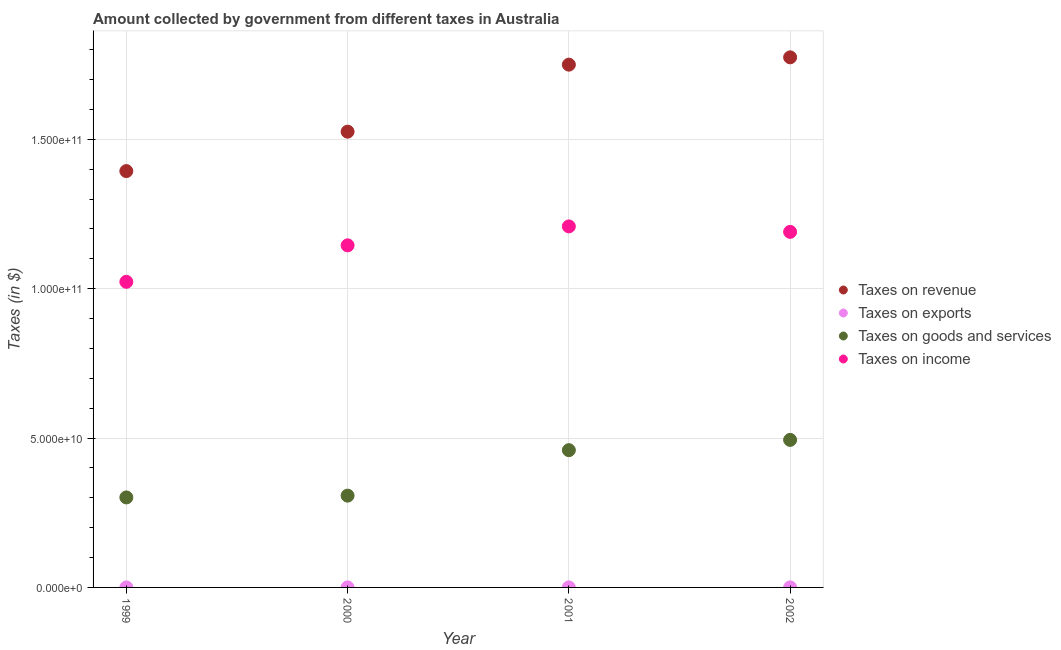Is the number of dotlines equal to the number of legend labels?
Keep it short and to the point. Yes. What is the amount collected as tax on income in 2002?
Provide a short and direct response. 1.19e+11. Across all years, what is the maximum amount collected as tax on income?
Provide a succinct answer. 1.21e+11. Across all years, what is the minimum amount collected as tax on goods?
Your response must be concise. 3.01e+1. In which year was the amount collected as tax on goods maximum?
Offer a terse response. 2002. In which year was the amount collected as tax on exports minimum?
Keep it short and to the point. 1999. What is the total amount collected as tax on income in the graph?
Provide a short and direct response. 4.57e+11. What is the difference between the amount collected as tax on income in 2000 and that in 2002?
Your answer should be compact. -4.51e+09. What is the difference between the amount collected as tax on goods in 1999 and the amount collected as tax on income in 2002?
Offer a terse response. -8.89e+1. What is the average amount collected as tax on revenue per year?
Give a very brief answer. 1.61e+11. In the year 1999, what is the difference between the amount collected as tax on revenue and amount collected as tax on exports?
Make the answer very short. 1.39e+11. In how many years, is the amount collected as tax on goods greater than 50000000000 $?
Offer a very short reply. 0. What is the ratio of the amount collected as tax on revenue in 2001 to that in 2002?
Offer a very short reply. 0.99. Is the amount collected as tax on revenue in 2000 less than that in 2002?
Your response must be concise. Yes. Is the difference between the amount collected as tax on goods in 2001 and 2002 greater than the difference between the amount collected as tax on revenue in 2001 and 2002?
Your answer should be very brief. No. What is the difference between the highest and the second highest amount collected as tax on goods?
Make the answer very short. 3.44e+09. What is the difference between the highest and the lowest amount collected as tax on exports?
Offer a very short reply. 1.00e+07. In how many years, is the amount collected as tax on goods greater than the average amount collected as tax on goods taken over all years?
Ensure brevity in your answer.  2. Is the sum of the amount collected as tax on income in 2001 and 2002 greater than the maximum amount collected as tax on goods across all years?
Your answer should be very brief. Yes. Is it the case that in every year, the sum of the amount collected as tax on goods and amount collected as tax on exports is greater than the sum of amount collected as tax on income and amount collected as tax on revenue?
Provide a succinct answer. No. Is the amount collected as tax on income strictly less than the amount collected as tax on exports over the years?
Provide a succinct answer. No. How many dotlines are there?
Your response must be concise. 4. What is the difference between two consecutive major ticks on the Y-axis?
Provide a succinct answer. 5.00e+1. Are the values on the major ticks of Y-axis written in scientific E-notation?
Provide a succinct answer. Yes. Does the graph contain any zero values?
Offer a very short reply. No. Does the graph contain grids?
Provide a short and direct response. Yes. Where does the legend appear in the graph?
Keep it short and to the point. Center right. How many legend labels are there?
Your answer should be compact. 4. How are the legend labels stacked?
Ensure brevity in your answer.  Vertical. What is the title of the graph?
Your response must be concise. Amount collected by government from different taxes in Australia. What is the label or title of the Y-axis?
Offer a very short reply. Taxes (in $). What is the Taxes (in $) in Taxes on revenue in 1999?
Keep it short and to the point. 1.39e+11. What is the Taxes (in $) of Taxes on goods and services in 1999?
Your response must be concise. 3.01e+1. What is the Taxes (in $) in Taxes on income in 1999?
Offer a terse response. 1.02e+11. What is the Taxes (in $) in Taxes on revenue in 2000?
Give a very brief answer. 1.53e+11. What is the Taxes (in $) of Taxes on goods and services in 2000?
Ensure brevity in your answer.  3.07e+1. What is the Taxes (in $) in Taxes on income in 2000?
Your answer should be compact. 1.15e+11. What is the Taxes (in $) in Taxes on revenue in 2001?
Ensure brevity in your answer.  1.75e+11. What is the Taxes (in $) of Taxes on exports in 2001?
Offer a very short reply. 1.40e+07. What is the Taxes (in $) of Taxes on goods and services in 2001?
Your response must be concise. 4.60e+1. What is the Taxes (in $) in Taxes on income in 2001?
Ensure brevity in your answer.  1.21e+11. What is the Taxes (in $) in Taxes on revenue in 2002?
Keep it short and to the point. 1.77e+11. What is the Taxes (in $) in Taxes on exports in 2002?
Give a very brief answer. 1.40e+07. What is the Taxes (in $) of Taxes on goods and services in 2002?
Give a very brief answer. 4.94e+1. What is the Taxes (in $) in Taxes on income in 2002?
Provide a succinct answer. 1.19e+11. Across all years, what is the maximum Taxes (in $) in Taxes on revenue?
Your answer should be very brief. 1.77e+11. Across all years, what is the maximum Taxes (in $) of Taxes on exports?
Ensure brevity in your answer.  1.40e+07. Across all years, what is the maximum Taxes (in $) in Taxes on goods and services?
Offer a terse response. 4.94e+1. Across all years, what is the maximum Taxes (in $) in Taxes on income?
Offer a very short reply. 1.21e+11. Across all years, what is the minimum Taxes (in $) in Taxes on revenue?
Give a very brief answer. 1.39e+11. Across all years, what is the minimum Taxes (in $) in Taxes on goods and services?
Give a very brief answer. 3.01e+1. Across all years, what is the minimum Taxes (in $) in Taxes on income?
Your response must be concise. 1.02e+11. What is the total Taxes (in $) in Taxes on revenue in the graph?
Ensure brevity in your answer.  6.44e+11. What is the total Taxes (in $) in Taxes on exports in the graph?
Keep it short and to the point. 4.40e+07. What is the total Taxes (in $) in Taxes on goods and services in the graph?
Your answer should be very brief. 1.56e+11. What is the total Taxes (in $) of Taxes on income in the graph?
Your response must be concise. 4.57e+11. What is the difference between the Taxes (in $) in Taxes on revenue in 1999 and that in 2000?
Keep it short and to the point. -1.32e+1. What is the difference between the Taxes (in $) in Taxes on exports in 1999 and that in 2000?
Offer a terse response. -8.00e+06. What is the difference between the Taxes (in $) of Taxes on goods and services in 1999 and that in 2000?
Offer a terse response. -5.99e+08. What is the difference between the Taxes (in $) of Taxes on income in 1999 and that in 2000?
Provide a succinct answer. -1.22e+1. What is the difference between the Taxes (in $) in Taxes on revenue in 1999 and that in 2001?
Ensure brevity in your answer.  -3.56e+1. What is the difference between the Taxes (in $) of Taxes on exports in 1999 and that in 2001?
Provide a short and direct response. -1.00e+07. What is the difference between the Taxes (in $) in Taxes on goods and services in 1999 and that in 2001?
Provide a succinct answer. -1.58e+1. What is the difference between the Taxes (in $) of Taxes on income in 1999 and that in 2001?
Your answer should be compact. -1.86e+1. What is the difference between the Taxes (in $) of Taxes on revenue in 1999 and that in 2002?
Ensure brevity in your answer.  -3.81e+1. What is the difference between the Taxes (in $) of Taxes on exports in 1999 and that in 2002?
Provide a short and direct response. -1.00e+07. What is the difference between the Taxes (in $) of Taxes on goods and services in 1999 and that in 2002?
Keep it short and to the point. -1.93e+1. What is the difference between the Taxes (in $) in Taxes on income in 1999 and that in 2002?
Offer a very short reply. -1.67e+1. What is the difference between the Taxes (in $) of Taxes on revenue in 2000 and that in 2001?
Make the answer very short. -2.24e+1. What is the difference between the Taxes (in $) of Taxes on goods and services in 2000 and that in 2001?
Ensure brevity in your answer.  -1.52e+1. What is the difference between the Taxes (in $) of Taxes on income in 2000 and that in 2001?
Provide a succinct answer. -6.34e+09. What is the difference between the Taxes (in $) in Taxes on revenue in 2000 and that in 2002?
Offer a very short reply. -2.49e+1. What is the difference between the Taxes (in $) of Taxes on goods and services in 2000 and that in 2002?
Your answer should be very brief. -1.87e+1. What is the difference between the Taxes (in $) of Taxes on income in 2000 and that in 2002?
Offer a very short reply. -4.51e+09. What is the difference between the Taxes (in $) of Taxes on revenue in 2001 and that in 2002?
Provide a short and direct response. -2.45e+09. What is the difference between the Taxes (in $) of Taxes on goods and services in 2001 and that in 2002?
Ensure brevity in your answer.  -3.44e+09. What is the difference between the Taxes (in $) in Taxes on income in 2001 and that in 2002?
Provide a short and direct response. 1.83e+09. What is the difference between the Taxes (in $) of Taxes on revenue in 1999 and the Taxes (in $) of Taxes on exports in 2000?
Make the answer very short. 1.39e+11. What is the difference between the Taxes (in $) of Taxes on revenue in 1999 and the Taxes (in $) of Taxes on goods and services in 2000?
Ensure brevity in your answer.  1.09e+11. What is the difference between the Taxes (in $) in Taxes on revenue in 1999 and the Taxes (in $) in Taxes on income in 2000?
Offer a very short reply. 2.49e+1. What is the difference between the Taxes (in $) of Taxes on exports in 1999 and the Taxes (in $) of Taxes on goods and services in 2000?
Provide a short and direct response. -3.07e+1. What is the difference between the Taxes (in $) in Taxes on exports in 1999 and the Taxes (in $) in Taxes on income in 2000?
Your response must be concise. -1.15e+11. What is the difference between the Taxes (in $) of Taxes on goods and services in 1999 and the Taxes (in $) of Taxes on income in 2000?
Offer a terse response. -8.44e+1. What is the difference between the Taxes (in $) in Taxes on revenue in 1999 and the Taxes (in $) in Taxes on exports in 2001?
Give a very brief answer. 1.39e+11. What is the difference between the Taxes (in $) of Taxes on revenue in 1999 and the Taxes (in $) of Taxes on goods and services in 2001?
Your response must be concise. 9.34e+1. What is the difference between the Taxes (in $) in Taxes on revenue in 1999 and the Taxes (in $) in Taxes on income in 2001?
Ensure brevity in your answer.  1.85e+1. What is the difference between the Taxes (in $) of Taxes on exports in 1999 and the Taxes (in $) of Taxes on goods and services in 2001?
Your answer should be compact. -4.60e+1. What is the difference between the Taxes (in $) of Taxes on exports in 1999 and the Taxes (in $) of Taxes on income in 2001?
Provide a succinct answer. -1.21e+11. What is the difference between the Taxes (in $) of Taxes on goods and services in 1999 and the Taxes (in $) of Taxes on income in 2001?
Keep it short and to the point. -9.07e+1. What is the difference between the Taxes (in $) in Taxes on revenue in 1999 and the Taxes (in $) in Taxes on exports in 2002?
Keep it short and to the point. 1.39e+11. What is the difference between the Taxes (in $) of Taxes on revenue in 1999 and the Taxes (in $) of Taxes on goods and services in 2002?
Offer a very short reply. 9.00e+1. What is the difference between the Taxes (in $) in Taxes on revenue in 1999 and the Taxes (in $) in Taxes on income in 2002?
Keep it short and to the point. 2.03e+1. What is the difference between the Taxes (in $) of Taxes on exports in 1999 and the Taxes (in $) of Taxes on goods and services in 2002?
Your answer should be compact. -4.94e+1. What is the difference between the Taxes (in $) in Taxes on exports in 1999 and the Taxes (in $) in Taxes on income in 2002?
Provide a succinct answer. -1.19e+11. What is the difference between the Taxes (in $) of Taxes on goods and services in 1999 and the Taxes (in $) of Taxes on income in 2002?
Keep it short and to the point. -8.89e+1. What is the difference between the Taxes (in $) in Taxes on revenue in 2000 and the Taxes (in $) in Taxes on exports in 2001?
Keep it short and to the point. 1.53e+11. What is the difference between the Taxes (in $) of Taxes on revenue in 2000 and the Taxes (in $) of Taxes on goods and services in 2001?
Ensure brevity in your answer.  1.07e+11. What is the difference between the Taxes (in $) in Taxes on revenue in 2000 and the Taxes (in $) in Taxes on income in 2001?
Provide a short and direct response. 3.17e+1. What is the difference between the Taxes (in $) of Taxes on exports in 2000 and the Taxes (in $) of Taxes on goods and services in 2001?
Your response must be concise. -4.59e+1. What is the difference between the Taxes (in $) of Taxes on exports in 2000 and the Taxes (in $) of Taxes on income in 2001?
Keep it short and to the point. -1.21e+11. What is the difference between the Taxes (in $) in Taxes on goods and services in 2000 and the Taxes (in $) in Taxes on income in 2001?
Offer a terse response. -9.01e+1. What is the difference between the Taxes (in $) of Taxes on revenue in 2000 and the Taxes (in $) of Taxes on exports in 2002?
Provide a succinct answer. 1.53e+11. What is the difference between the Taxes (in $) of Taxes on revenue in 2000 and the Taxes (in $) of Taxes on goods and services in 2002?
Your answer should be compact. 1.03e+11. What is the difference between the Taxes (in $) in Taxes on revenue in 2000 and the Taxes (in $) in Taxes on income in 2002?
Provide a short and direct response. 3.35e+1. What is the difference between the Taxes (in $) in Taxes on exports in 2000 and the Taxes (in $) in Taxes on goods and services in 2002?
Give a very brief answer. -4.94e+1. What is the difference between the Taxes (in $) of Taxes on exports in 2000 and the Taxes (in $) of Taxes on income in 2002?
Your response must be concise. -1.19e+11. What is the difference between the Taxes (in $) in Taxes on goods and services in 2000 and the Taxes (in $) in Taxes on income in 2002?
Offer a terse response. -8.83e+1. What is the difference between the Taxes (in $) in Taxes on revenue in 2001 and the Taxes (in $) in Taxes on exports in 2002?
Ensure brevity in your answer.  1.75e+11. What is the difference between the Taxes (in $) in Taxes on revenue in 2001 and the Taxes (in $) in Taxes on goods and services in 2002?
Give a very brief answer. 1.26e+11. What is the difference between the Taxes (in $) in Taxes on revenue in 2001 and the Taxes (in $) in Taxes on income in 2002?
Give a very brief answer. 5.60e+1. What is the difference between the Taxes (in $) in Taxes on exports in 2001 and the Taxes (in $) in Taxes on goods and services in 2002?
Your answer should be compact. -4.94e+1. What is the difference between the Taxes (in $) of Taxes on exports in 2001 and the Taxes (in $) of Taxes on income in 2002?
Give a very brief answer. -1.19e+11. What is the difference between the Taxes (in $) of Taxes on goods and services in 2001 and the Taxes (in $) of Taxes on income in 2002?
Your response must be concise. -7.31e+1. What is the average Taxes (in $) of Taxes on revenue per year?
Your answer should be compact. 1.61e+11. What is the average Taxes (in $) of Taxes on exports per year?
Your answer should be compact. 1.10e+07. What is the average Taxes (in $) in Taxes on goods and services per year?
Provide a short and direct response. 3.90e+1. What is the average Taxes (in $) of Taxes on income per year?
Offer a very short reply. 1.14e+11. In the year 1999, what is the difference between the Taxes (in $) of Taxes on revenue and Taxes (in $) of Taxes on exports?
Your answer should be compact. 1.39e+11. In the year 1999, what is the difference between the Taxes (in $) in Taxes on revenue and Taxes (in $) in Taxes on goods and services?
Your response must be concise. 1.09e+11. In the year 1999, what is the difference between the Taxes (in $) in Taxes on revenue and Taxes (in $) in Taxes on income?
Your answer should be very brief. 3.71e+1. In the year 1999, what is the difference between the Taxes (in $) in Taxes on exports and Taxes (in $) in Taxes on goods and services?
Your answer should be very brief. -3.01e+1. In the year 1999, what is the difference between the Taxes (in $) in Taxes on exports and Taxes (in $) in Taxes on income?
Ensure brevity in your answer.  -1.02e+11. In the year 1999, what is the difference between the Taxes (in $) in Taxes on goods and services and Taxes (in $) in Taxes on income?
Offer a very short reply. -7.22e+1. In the year 2000, what is the difference between the Taxes (in $) of Taxes on revenue and Taxes (in $) of Taxes on exports?
Provide a succinct answer. 1.53e+11. In the year 2000, what is the difference between the Taxes (in $) in Taxes on revenue and Taxes (in $) in Taxes on goods and services?
Offer a terse response. 1.22e+11. In the year 2000, what is the difference between the Taxes (in $) in Taxes on revenue and Taxes (in $) in Taxes on income?
Your response must be concise. 3.81e+1. In the year 2000, what is the difference between the Taxes (in $) of Taxes on exports and Taxes (in $) of Taxes on goods and services?
Provide a succinct answer. -3.07e+1. In the year 2000, what is the difference between the Taxes (in $) in Taxes on exports and Taxes (in $) in Taxes on income?
Your response must be concise. -1.15e+11. In the year 2000, what is the difference between the Taxes (in $) in Taxes on goods and services and Taxes (in $) in Taxes on income?
Offer a terse response. -8.38e+1. In the year 2001, what is the difference between the Taxes (in $) of Taxes on revenue and Taxes (in $) of Taxes on exports?
Your response must be concise. 1.75e+11. In the year 2001, what is the difference between the Taxes (in $) in Taxes on revenue and Taxes (in $) in Taxes on goods and services?
Your answer should be very brief. 1.29e+11. In the year 2001, what is the difference between the Taxes (in $) of Taxes on revenue and Taxes (in $) of Taxes on income?
Your response must be concise. 5.42e+1. In the year 2001, what is the difference between the Taxes (in $) of Taxes on exports and Taxes (in $) of Taxes on goods and services?
Keep it short and to the point. -4.59e+1. In the year 2001, what is the difference between the Taxes (in $) of Taxes on exports and Taxes (in $) of Taxes on income?
Your answer should be very brief. -1.21e+11. In the year 2001, what is the difference between the Taxes (in $) of Taxes on goods and services and Taxes (in $) of Taxes on income?
Provide a short and direct response. -7.49e+1. In the year 2002, what is the difference between the Taxes (in $) in Taxes on revenue and Taxes (in $) in Taxes on exports?
Provide a succinct answer. 1.77e+11. In the year 2002, what is the difference between the Taxes (in $) of Taxes on revenue and Taxes (in $) of Taxes on goods and services?
Your response must be concise. 1.28e+11. In the year 2002, what is the difference between the Taxes (in $) of Taxes on revenue and Taxes (in $) of Taxes on income?
Offer a terse response. 5.84e+1. In the year 2002, what is the difference between the Taxes (in $) of Taxes on exports and Taxes (in $) of Taxes on goods and services?
Give a very brief answer. -4.94e+1. In the year 2002, what is the difference between the Taxes (in $) of Taxes on exports and Taxes (in $) of Taxes on income?
Provide a succinct answer. -1.19e+11. In the year 2002, what is the difference between the Taxes (in $) of Taxes on goods and services and Taxes (in $) of Taxes on income?
Make the answer very short. -6.96e+1. What is the ratio of the Taxes (in $) of Taxes on revenue in 1999 to that in 2000?
Ensure brevity in your answer.  0.91. What is the ratio of the Taxes (in $) of Taxes on exports in 1999 to that in 2000?
Ensure brevity in your answer.  0.33. What is the ratio of the Taxes (in $) in Taxes on goods and services in 1999 to that in 2000?
Keep it short and to the point. 0.98. What is the ratio of the Taxes (in $) of Taxes on income in 1999 to that in 2000?
Provide a short and direct response. 0.89. What is the ratio of the Taxes (in $) of Taxes on revenue in 1999 to that in 2001?
Your answer should be very brief. 0.8. What is the ratio of the Taxes (in $) of Taxes on exports in 1999 to that in 2001?
Ensure brevity in your answer.  0.29. What is the ratio of the Taxes (in $) in Taxes on goods and services in 1999 to that in 2001?
Keep it short and to the point. 0.66. What is the ratio of the Taxes (in $) of Taxes on income in 1999 to that in 2001?
Keep it short and to the point. 0.85. What is the ratio of the Taxes (in $) in Taxes on revenue in 1999 to that in 2002?
Offer a terse response. 0.79. What is the ratio of the Taxes (in $) in Taxes on exports in 1999 to that in 2002?
Your answer should be compact. 0.29. What is the ratio of the Taxes (in $) of Taxes on goods and services in 1999 to that in 2002?
Give a very brief answer. 0.61. What is the ratio of the Taxes (in $) in Taxes on income in 1999 to that in 2002?
Your response must be concise. 0.86. What is the ratio of the Taxes (in $) in Taxes on revenue in 2000 to that in 2001?
Offer a very short reply. 0.87. What is the ratio of the Taxes (in $) in Taxes on goods and services in 2000 to that in 2001?
Give a very brief answer. 0.67. What is the ratio of the Taxes (in $) of Taxes on income in 2000 to that in 2001?
Your response must be concise. 0.95. What is the ratio of the Taxes (in $) of Taxes on revenue in 2000 to that in 2002?
Provide a succinct answer. 0.86. What is the ratio of the Taxes (in $) in Taxes on goods and services in 2000 to that in 2002?
Offer a very short reply. 0.62. What is the ratio of the Taxes (in $) in Taxes on income in 2000 to that in 2002?
Your answer should be compact. 0.96. What is the ratio of the Taxes (in $) in Taxes on revenue in 2001 to that in 2002?
Provide a short and direct response. 0.99. What is the ratio of the Taxes (in $) in Taxes on goods and services in 2001 to that in 2002?
Make the answer very short. 0.93. What is the ratio of the Taxes (in $) in Taxes on income in 2001 to that in 2002?
Provide a succinct answer. 1.02. What is the difference between the highest and the second highest Taxes (in $) of Taxes on revenue?
Ensure brevity in your answer.  2.45e+09. What is the difference between the highest and the second highest Taxes (in $) of Taxes on exports?
Your response must be concise. 0. What is the difference between the highest and the second highest Taxes (in $) in Taxes on goods and services?
Keep it short and to the point. 3.44e+09. What is the difference between the highest and the second highest Taxes (in $) in Taxes on income?
Your response must be concise. 1.83e+09. What is the difference between the highest and the lowest Taxes (in $) of Taxes on revenue?
Make the answer very short. 3.81e+1. What is the difference between the highest and the lowest Taxes (in $) in Taxes on goods and services?
Give a very brief answer. 1.93e+1. What is the difference between the highest and the lowest Taxes (in $) in Taxes on income?
Provide a short and direct response. 1.86e+1. 